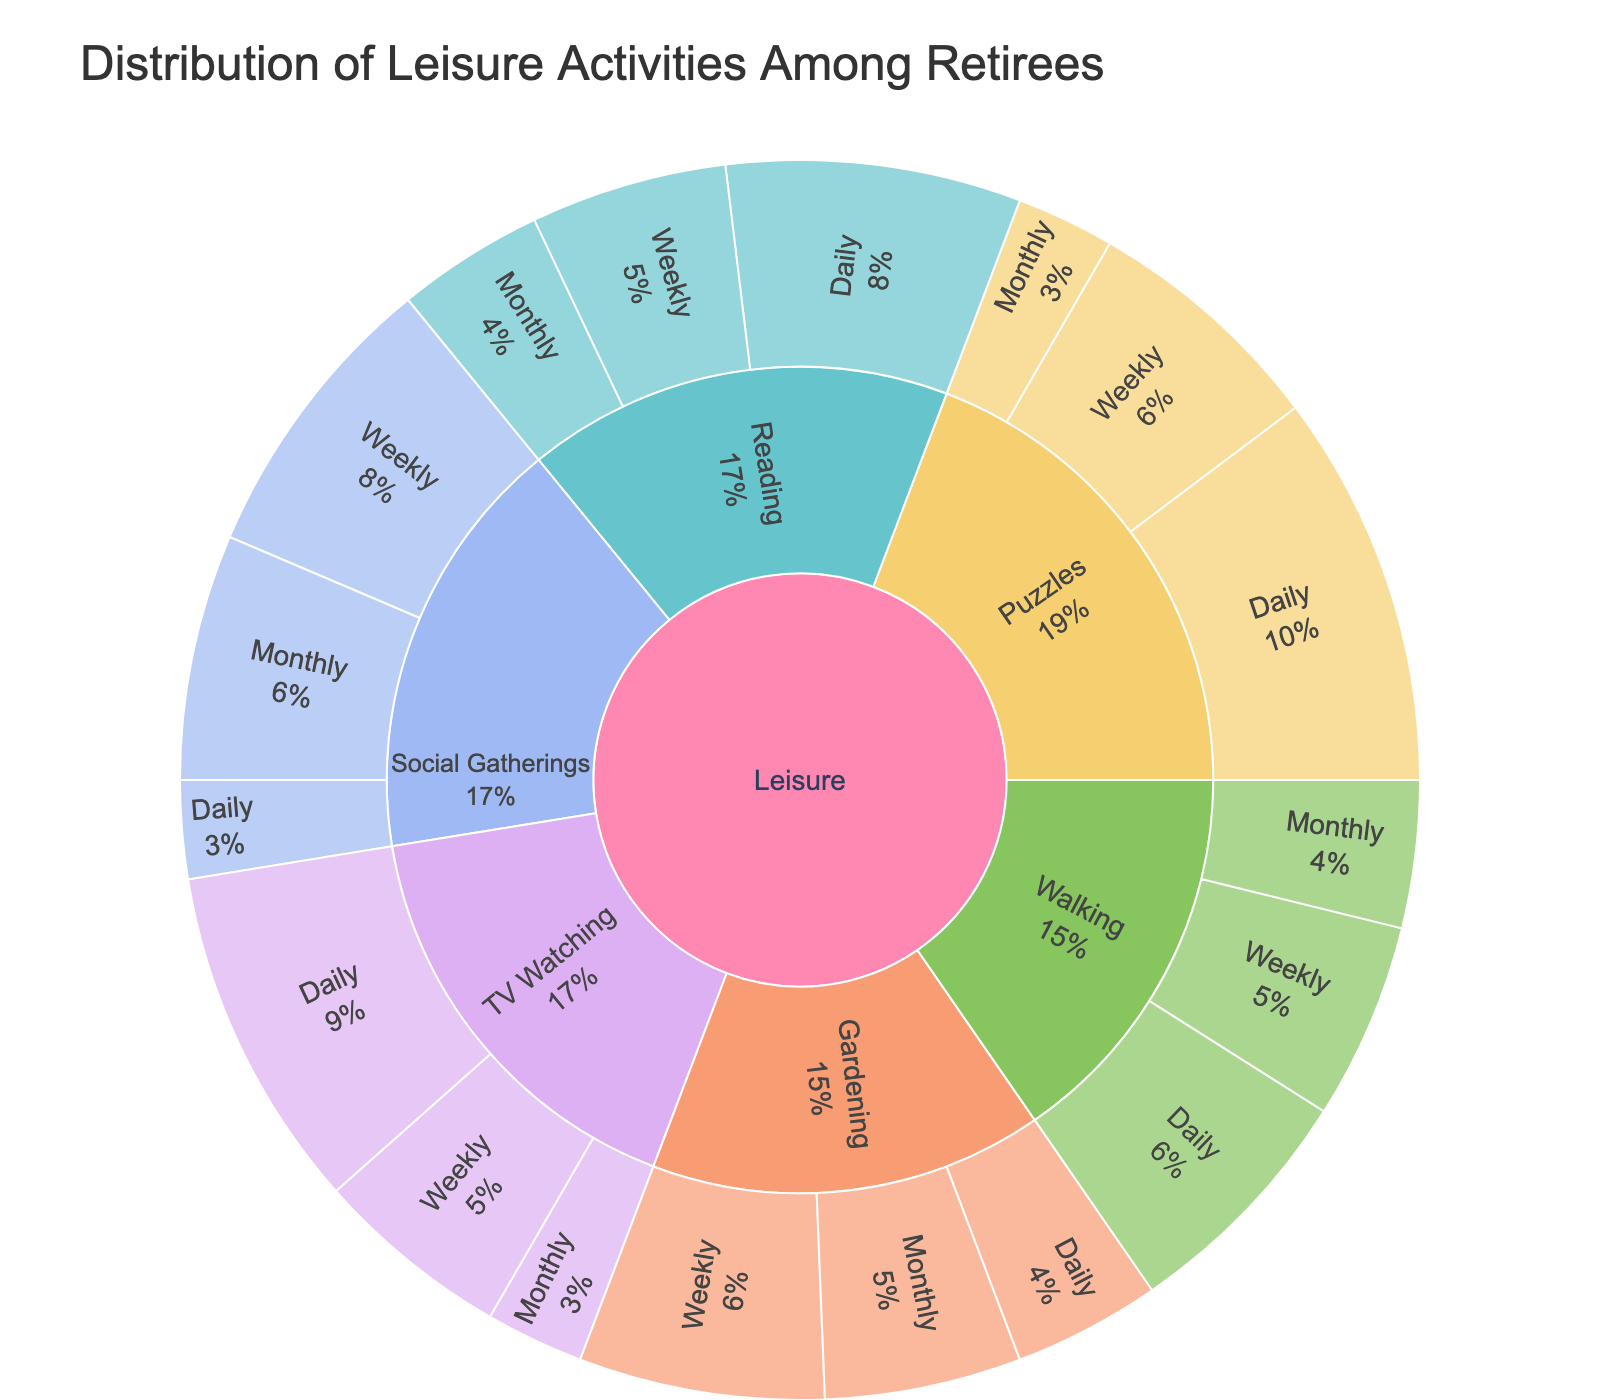what type of leisure activity is engaged in daily by the highest percentage of retirees? Examine the sunburst plot, focusing on the "Daily" segments under each Activity category. Identify the daily segments with the largest size.
Answer: Puzzles How many different Leisure Activities are represented in the plot? Look at the plot's top level, which should show the primary categories or activities. Count these segments.
Answer: 6 Which activity is done weekly by the highest number of retirees? Check the "Weekly" sub-segments for each Activity category and compare their sizes.
Answer: Social Gatherings What's the combined value of retirees who engage in Walking either daily, weekly, or monthly? Find the segments for Walking under Daily, Weekly, and Monthly, then sum their values (25 + 20 + 15).
Answer: 60 Are there more retirees who watch TV or read daily? Compare the size of the "Daily" segments under TV Watching and Reading categories.
Answer: TV Watching What's the least frequent gardening activity? Examine the "Gardening" category and identify the segment with the smallest value.
Answer: Daily Which activity has the most evenly distributed frequency across daily, weekly, and monthly? Compare the three frequency segments for each activity and look for the one with values that are close to each other.
Answer: Reading How many retirees engage in weekly TV watching and weekly walking, combined? Add the values of the Weekly segments for TV Watching and Walking (20 + 20).
Answer: 40 Is puzzle-solving more popular daily or weekly? Compare the size of the Daily and Weekly segments under the Puzzles category.
Answer: Daily 